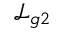Convert formula to latex. <formula><loc_0><loc_0><loc_500><loc_500>\mathcal { L } _ { g 2 }</formula> 